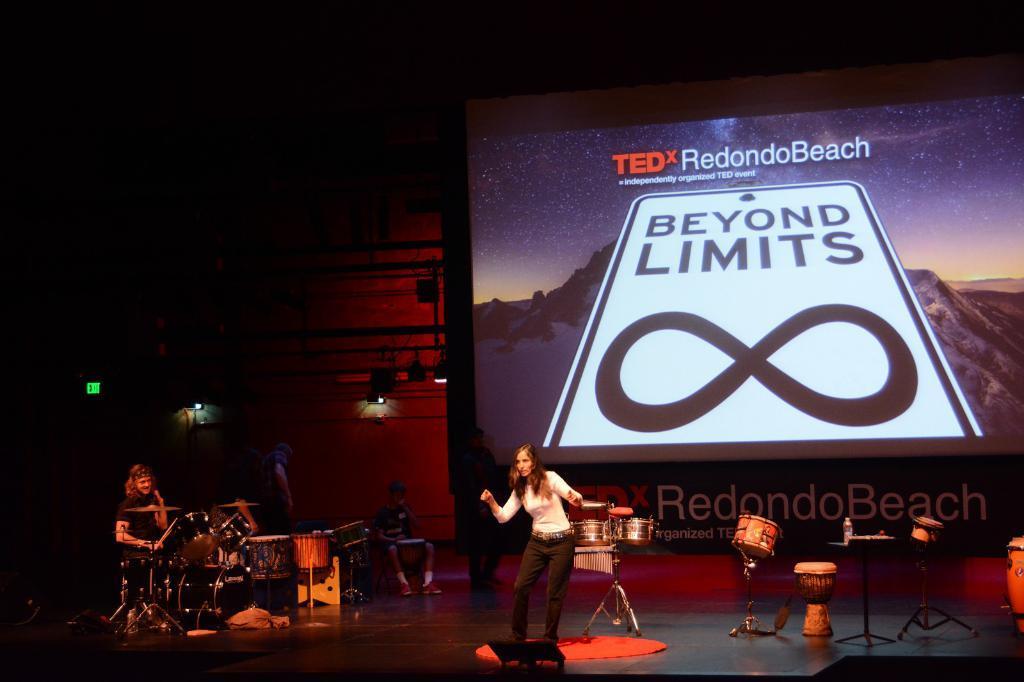Please provide a concise description of this image. This image is taken indoors. In the background there is a wall and there is a screen with an image and a text on it. In this image the background is a little dark. At the bottom of the image there is a dais. On the left side of the image a person is sitting on the stool and playing music with musical instruments. There are a few musical instruments. On the right side of the image there are few musical instruments on the dais. In the middle of the image a woman is standing on the dais. 